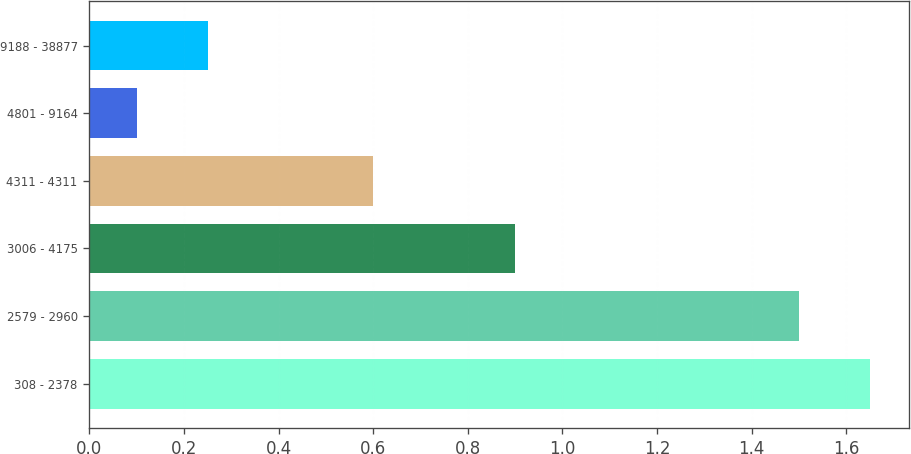Convert chart to OTSL. <chart><loc_0><loc_0><loc_500><loc_500><bar_chart><fcel>308 - 2378<fcel>2579 - 2960<fcel>3006 - 4175<fcel>4311 - 4311<fcel>4801 - 9164<fcel>9188 - 38877<nl><fcel>1.65<fcel>1.5<fcel>0.9<fcel>0.6<fcel>0.1<fcel>0.25<nl></chart> 